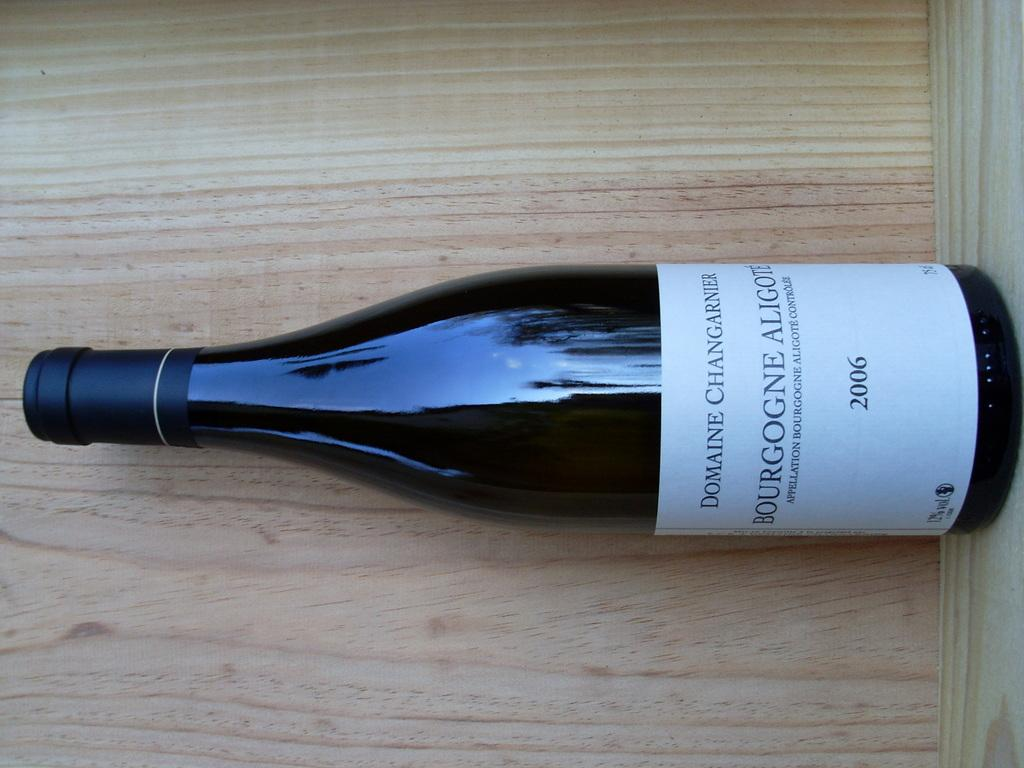<image>
Summarize the visual content of the image. A bottle with a white label that says domaine changarier. 